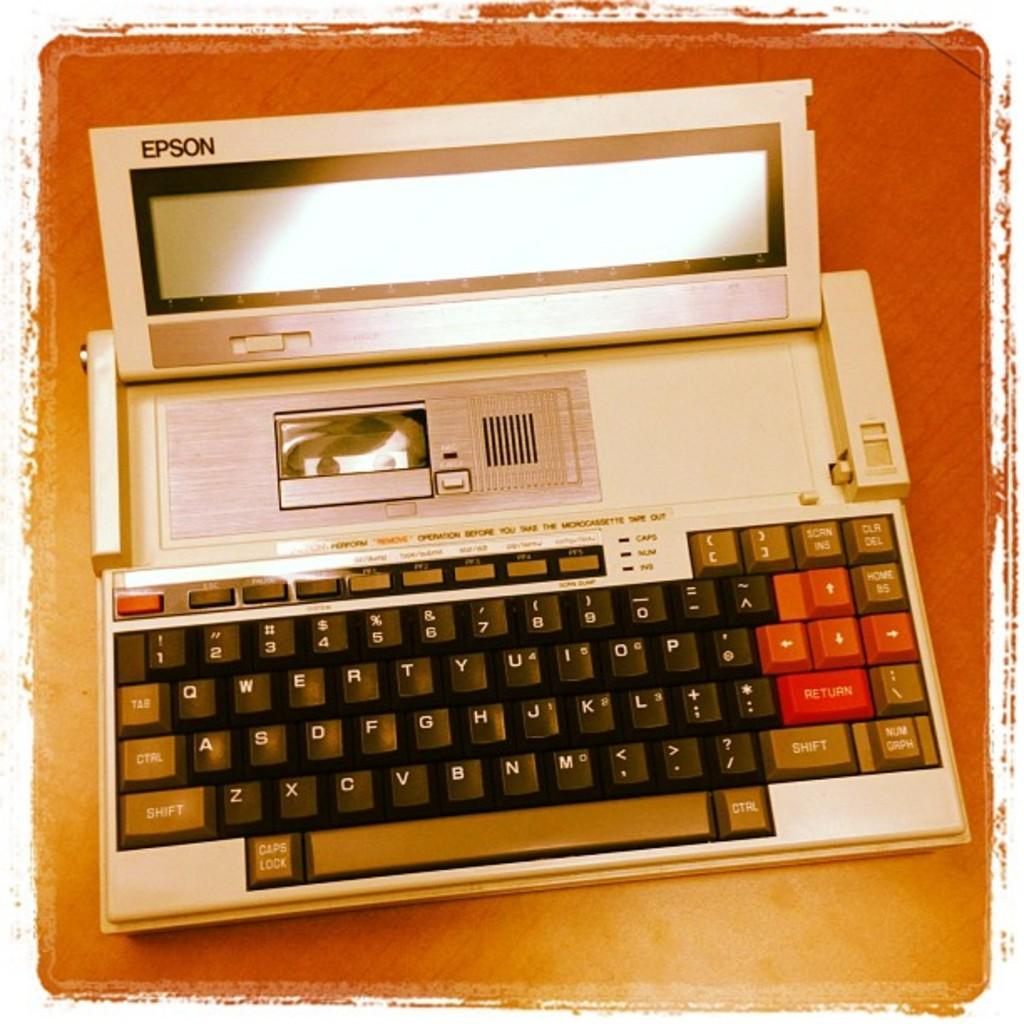<image>
Offer a succinct explanation of the picture presented. Keyboard that has a screen on it by Epson. 